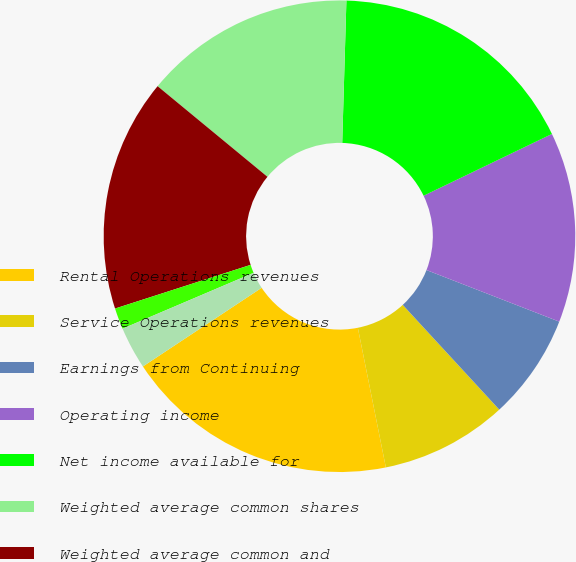Convert chart. <chart><loc_0><loc_0><loc_500><loc_500><pie_chart><fcel>Rental Operations revenues<fcel>Service Operations revenues<fcel>Earnings from Continuing<fcel>Operating income<fcel>Net income available for<fcel>Weighted average common shares<fcel>Weighted average common and<fcel>Continuing operations<fcel>Discontinued operations<nl><fcel>18.84%<fcel>8.7%<fcel>7.25%<fcel>13.04%<fcel>17.39%<fcel>14.49%<fcel>15.94%<fcel>1.45%<fcel>2.9%<nl></chart> 